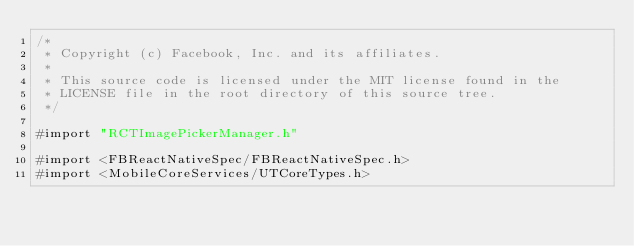Convert code to text. <code><loc_0><loc_0><loc_500><loc_500><_ObjectiveC_>/*
 * Copyright (c) Facebook, Inc. and its affiliates.
 *
 * This source code is licensed under the MIT license found in the
 * LICENSE file in the root directory of this source tree.
 */

#import "RCTImagePickerManager.h"

#import <FBReactNativeSpec/FBReactNativeSpec.h>
#import <MobileCoreServices/UTCoreTypes.h></code> 